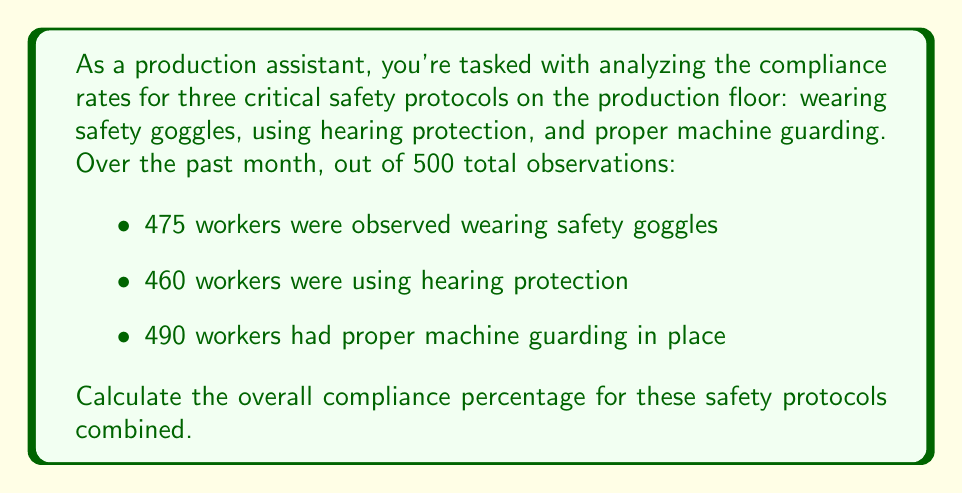Give your solution to this math problem. To calculate the overall compliance percentage, we need to follow these steps:

1. Calculate the total number of compliant observations:
   $475 + 460 + 490 = 1425$ compliant observations

2. Calculate the total number of possible observations:
   $500 \times 3 = 1500$ total possible observations (500 for each of the 3 protocols)

3. Calculate the overall compliance percentage using the formula:

   $$\text{Compliance Percentage} = \frac{\text{Number of Compliant Observations}}{\text{Total Possible Observations}} \times 100\%$$

   $$\text{Compliance Percentage} = \frac{1425}{1500} \times 100\%$$

4. Perform the division:
   $$\frac{1425}{1500} = 0.95$$

5. Convert to a percentage:
   $$0.95 \times 100\% = 95\%$$

Therefore, the overall compliance percentage for these safety protocols combined is 95%.
Answer: 95% 